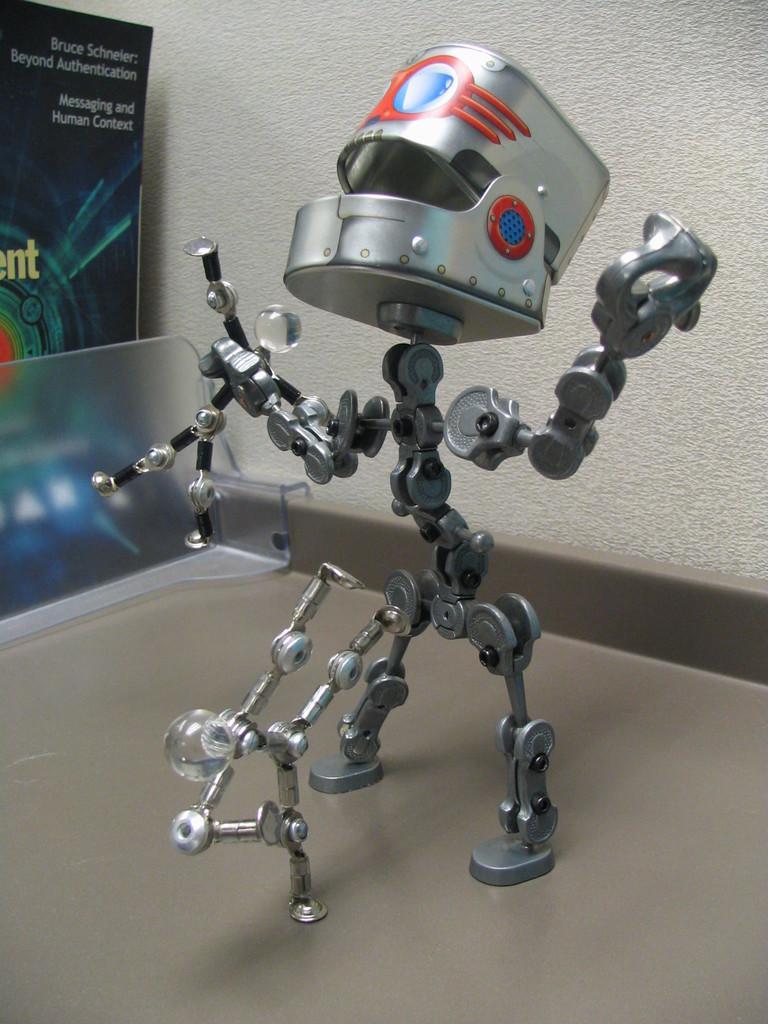Could you give a brief overview of what you see in this image? In this picture I can observe a robot on the floor. In the background there is a wall. 